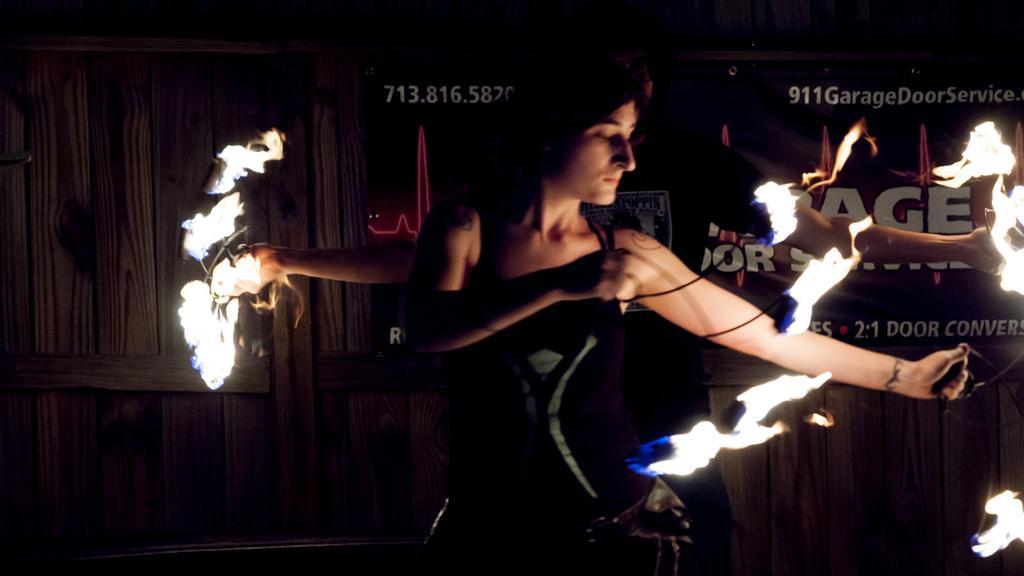Could you give a brief overview of what you see in this image? In this image person standing and playing with fire. 